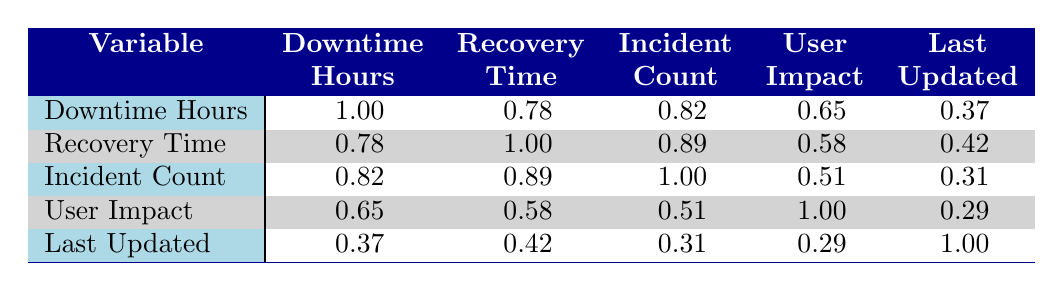What is the downtime in hours for the Social Media App? From the table, locate the row for SocialMediaApp and find the corresponding downtime hours, which is listed as 20 hours.
Answer: 20 What is the recovery time in minutes for the Finance Management App? By referencing the row for FinanceManagementApp in the table, the recovery time is found to be 15 minutes.
Answer: 15 Which application has the highest average user impact? Looking through the rows, SocialMediaApp has the highest average user impact at 3000.
Answer: SocialMediaApp Is the incident count for the Travel Booking System greater than that for the eCommerce Platform? The table shows the Incident Count for TravelBookingSystem is 5, and for eCommercePlatform, it is 3. Therefore, 5 is greater than 3.
Answer: Yes What is the correlation between downtime hours and recovery time? The table indicates a correlation of 0.78 between downtime hours and recovery time, which means they have a positive relationship.
Answer: 0.78 If we sum the downtime hours of all applications, what is the total? Add the downtime hours of each application: 12 + 8 + 20 + 5 + 10 + 15 = 70.
Answer: 70 What is the recovery time for the application with the highest incident count? The highest incident count is 5 for the Travel Booking System, which has a recovery time of 120 minutes.
Answer: 120 Is the average user impact for SaaS Analytics Tool below 1000? The average user impact for SaaSAnalyticsTool is 800, which is below 1000.
Answer: Yes What is the average recovery time of all applications listed? Calculate the total recovery time: 45 + 30 + 90 + 15 + 60 + 120 = 360 minutes. Then divide by the number of applications, which is 6, resulting in an average of 60 minutes.
Answer: 60 What is the correlation value between user impact and incident count? The table shows a correlation of 0.51 between user impact and incident count, indicating a moderate positive relationship.
Answer: 0.51 